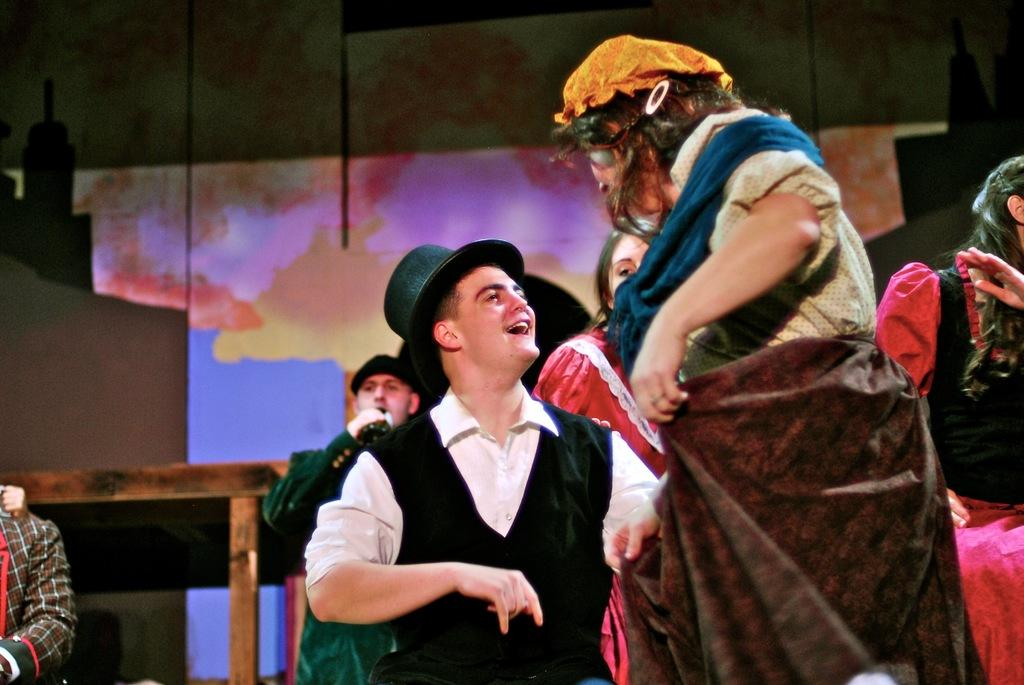What can be seen in the image? There are people standing in the image. Where is the table located in the image? The table is on the left side of the image. What is visible in the background of the image? There appears to be a wall in the background of the image. What is the man in the front wearing? The man in the front is wearing a cap. What type of brain can be seen on the table in the image? There is no brain present on the table in the image. What color is the chin of the man in the front? The chin of the man in the front cannot be determined from the image, as it is not visible. 